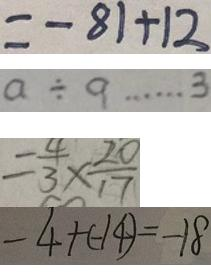Convert formula to latex. <formula><loc_0><loc_0><loc_500><loc_500>= - 8 1 + 1 2 
 a \div 9 \cdots 3 
 = \frac { 4 } { 3 } \times \frac { 2 0 } { 1 7 } 
 - 4 + ( - 1 4 ) = - 1 8</formula> 